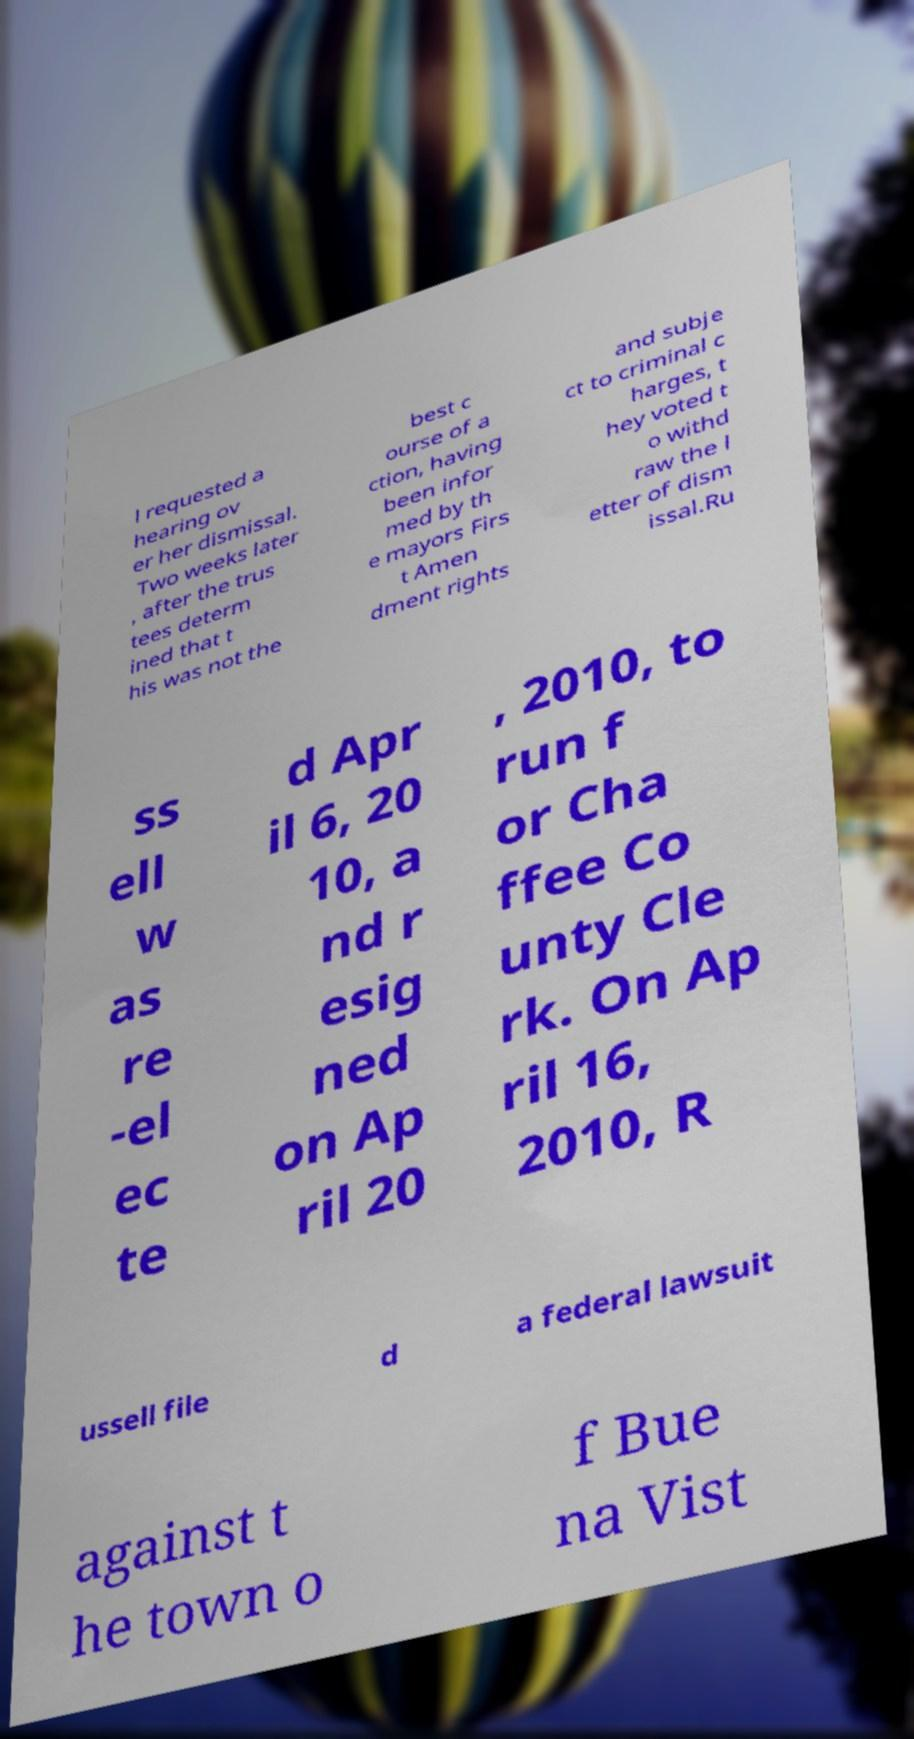Could you assist in decoding the text presented in this image and type it out clearly? l requested a hearing ov er her dismissal. Two weeks later , after the trus tees determ ined that t his was not the best c ourse of a ction, having been infor med by th e mayors Firs t Amen dment rights and subje ct to criminal c harges, t hey voted t o withd raw the l etter of dism issal.Ru ss ell w as re -el ec te d Apr il 6, 20 10, a nd r esig ned on Ap ril 20 , 2010, to run f or Cha ffee Co unty Cle rk. On Ap ril 16, 2010, R ussell file d a federal lawsuit against t he town o f Bue na Vist 